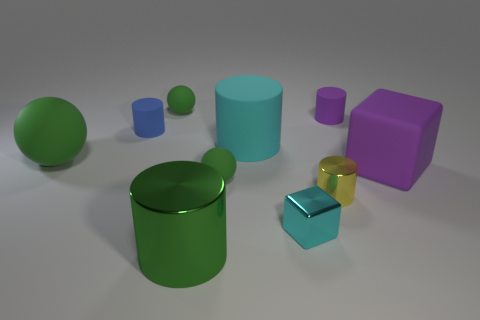The cyan thing on the left side of the tiny cyan cube has what shape?
Give a very brief answer. Cylinder. There is a purple object that is the same size as the cyan rubber object; what material is it?
Your answer should be very brief. Rubber. What number of things are either large rubber objects to the right of the small blue object or cylinders that are to the left of the metallic cube?
Your answer should be compact. 4. There is another cylinder that is the same material as the yellow cylinder; what is its size?
Your answer should be compact. Large. Are there the same number of large metal objects and large matte objects?
Keep it short and to the point. No. How many metallic objects are either small cyan things or tiny blue cylinders?
Offer a very short reply. 1. The yellow metal object has what size?
Offer a very short reply. Small. Is the cyan metallic block the same size as the yellow cylinder?
Offer a terse response. Yes. There is a green sphere that is behind the cyan cylinder; what is its material?
Your answer should be compact. Rubber. What is the material of the big purple object that is the same shape as the cyan shiny thing?
Your response must be concise. Rubber. 